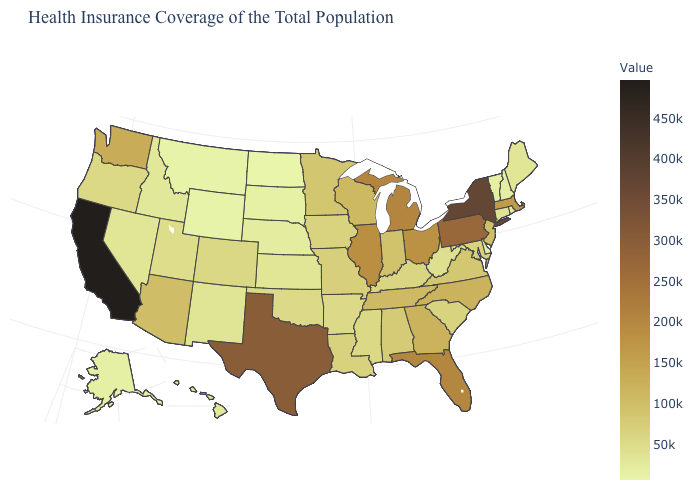Is the legend a continuous bar?
Keep it brief. Yes. Does the map have missing data?
Write a very short answer. No. Among the states that border Wyoming , does Colorado have the highest value?
Be succinct. Yes. Does California have the highest value in the USA?
Quick response, please. Yes. Does Washington have the highest value in the West?
Give a very brief answer. No. 